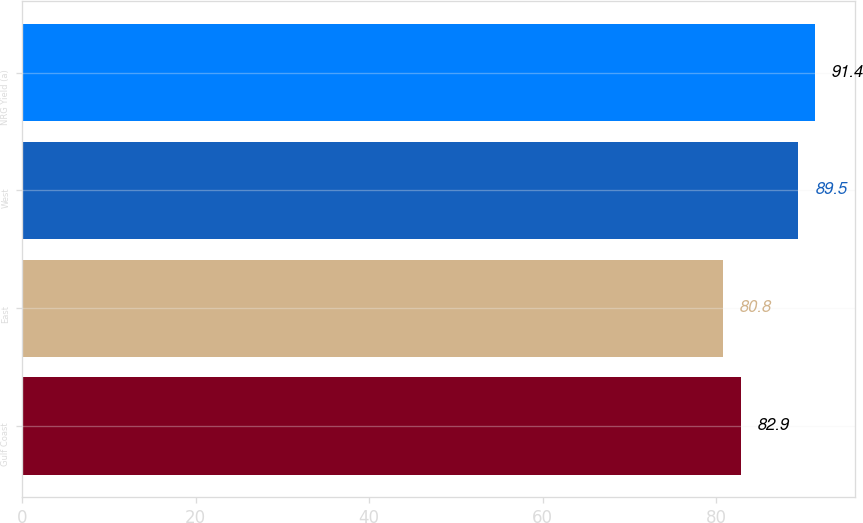Convert chart to OTSL. <chart><loc_0><loc_0><loc_500><loc_500><bar_chart><fcel>Gulf Coast<fcel>East<fcel>West<fcel>NRG Yield (a)<nl><fcel>82.9<fcel>80.8<fcel>89.5<fcel>91.4<nl></chart> 